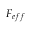<formula> <loc_0><loc_0><loc_500><loc_500>F _ { e f f }</formula> 